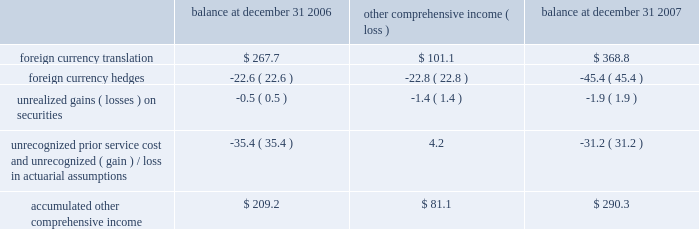Which , $ 44.9 million , or $ 38.2 million , net of taxes , is expected to be reclassified to earnings over the next twelve months .
We also enter into foreign currency forward exchange contracts with terms of one month to manage currency exposures for assets and liabilities denominated in a currency other than an entity 2019s functional currency .
As a result , any foreign currency translation gains/losses recognized in earnings under sfas no .
52 , 201cforeign currency translation 201d are generally offset with gains/losses on the foreign currency forward exchange contracts in the same reporting period .
Other comprehensive income 2013 other comprehensive income refers to revenues , expenses , gains and losses that under generally accepted accounting principles are included in comprehensive income but are excluded from net earnings as these amounts are recorded directly as an adjustment to stockholders 2019 equity .
Other comprehensive income is comprised of foreign currency translation adjustments , unrealized foreign currency hedge gains and losses , unrealized gains and losses on available-for-sale securities and amortization of prior service costs and unrecognized gains and losses in actuarial assumptions .
The components of accumulated other comprehensive income are as follows ( in millions ) : balance at december 31 , comprehensive income ( loss ) balance at december 31 .
Treasury stock 2013 we account for repurchases of common stock under the cost method and present treasury stock as a reduction of shareholders equity .
We may reissue common stock held in treasury only for limited purposes .
Accounting pronouncements 2013 in june 2006 , the fasb issued interpretation no .
48 , 201caccounting for uncertainty in income taxes , an interpretation of fas 109 , accounting for income taxes 201d ( fin 48 ) , to create a single model to address accounting for uncertainty in tax positions .
See our income tax disclosures in note 11 for more information regarding the adoption of fin 48 .
In september 2006 , the fasb issued sfas no .
158 , 201cemployers 2019 accounting for defined benefit pension and other postretirement plans 2013 an amendment of fasb statements no .
87 , 88 , 106 and 132 ( r ) . 201d this statement requires recognition of the funded status of a benefit plan in the statement of financial position .
Sfas no .
158 also requires recognition in other comprehensive income of certain gains and losses that arise during the period but are deferred under pension accounting rules , as well as modifies the timing of reporting and adds certain disclosures .
The statement provides recognition and disclosure elements to be effective as of the end of the fiscal year after december 15 , 2006 and measurement elements to be effective for fiscal years ending after december 15 , 2008 .
We adopted sfas no .
158 on december 31 , 2006 .
See our pension and other postretirement disclosures in note 10 .
In december 2004 , the fasb issued sfas no .
123 ( r ) , 201cshare-based payment 201d , which is a revision to sfas no .
123 .
Sfas 123 ( r ) requires all share-based payments to employees , including stock options , to be expensed based on their fair values .
We adopted sfas 123 ( r ) on january 1 , 2006 using the modified prospective method and did not restate prior periods .
In september 2006 , the fasb issued sfas no .
157 , 201cfair value measurements 201d , which defines fair value , establishes a framework for measuring fair value in generally accepted accounting principles and expands disclosures about fair value measurements .
This statement does not require any new fair value measurements , but provides guidance on how to measure fair value by providing a fair value hierarchy used to classify the source of the information .
Sfas no .
157 is effective for financial statements issued for fiscal years beginning after november 15 , 2007 and interim periods within those fiscal years .
In february 2008 , the fasb issued fasb staff position ( fsp ) no .
Sfas 157-2 , which delays the effective date of certain provisions of sfas no .
157 relating to non-financial assets and liabilities measured at fair value on a non-recurring basis until fiscal years beginning after november 15 , 2008 .
The adoption of sfas no .
157 is not expected to have a material impact on our consolidated financial statements or results of operations .
In february 2007 , the fasb issued sfas no .
159 , 201cthe fair value option for financial assets and financial liabilities 2013 including an amendment of fasb statement no .
115 201d ( sfas no .
159 ) .
Sfas no .
159 creates a 201cfair value option 201d under which an entity may elect to record certain financial assets or liabilities at fair value upon their initial recognition .
Subsequent changes in fair value would be recognized in earnings as those changes occur .
The election of the fair value option would be made on a contract-by-contract basis and would need to be supported by concurrent documentation or a preexisting documented policy .
Sfas no .
159 requires an entity to separately disclose the fair z i m m e r h o l d i n g s , i n c .
2 0 0 7 f o r m 1 0 - k a n n u a l r e p o r t notes to consolidated financial statements ( continued ) .
What percent of total accumulated other comprehensive income is from 2007? 
Computations: (81.1 / 290.3)
Answer: 0.27937. Which , $ 44.9 million , or $ 38.2 million , net of taxes , is expected to be reclassified to earnings over the next twelve months .
We also enter into foreign currency forward exchange contracts with terms of one month to manage currency exposures for assets and liabilities denominated in a currency other than an entity 2019s functional currency .
As a result , any foreign currency translation gains/losses recognized in earnings under sfas no .
52 , 201cforeign currency translation 201d are generally offset with gains/losses on the foreign currency forward exchange contracts in the same reporting period .
Other comprehensive income 2013 other comprehensive income refers to revenues , expenses , gains and losses that under generally accepted accounting principles are included in comprehensive income but are excluded from net earnings as these amounts are recorded directly as an adjustment to stockholders 2019 equity .
Other comprehensive income is comprised of foreign currency translation adjustments , unrealized foreign currency hedge gains and losses , unrealized gains and losses on available-for-sale securities and amortization of prior service costs and unrecognized gains and losses in actuarial assumptions .
The components of accumulated other comprehensive income are as follows ( in millions ) : balance at december 31 , comprehensive income ( loss ) balance at december 31 .
Treasury stock 2013 we account for repurchases of common stock under the cost method and present treasury stock as a reduction of shareholders equity .
We may reissue common stock held in treasury only for limited purposes .
Accounting pronouncements 2013 in june 2006 , the fasb issued interpretation no .
48 , 201caccounting for uncertainty in income taxes , an interpretation of fas 109 , accounting for income taxes 201d ( fin 48 ) , to create a single model to address accounting for uncertainty in tax positions .
See our income tax disclosures in note 11 for more information regarding the adoption of fin 48 .
In september 2006 , the fasb issued sfas no .
158 , 201cemployers 2019 accounting for defined benefit pension and other postretirement plans 2013 an amendment of fasb statements no .
87 , 88 , 106 and 132 ( r ) . 201d this statement requires recognition of the funded status of a benefit plan in the statement of financial position .
Sfas no .
158 also requires recognition in other comprehensive income of certain gains and losses that arise during the period but are deferred under pension accounting rules , as well as modifies the timing of reporting and adds certain disclosures .
The statement provides recognition and disclosure elements to be effective as of the end of the fiscal year after december 15 , 2006 and measurement elements to be effective for fiscal years ending after december 15 , 2008 .
We adopted sfas no .
158 on december 31 , 2006 .
See our pension and other postretirement disclosures in note 10 .
In december 2004 , the fasb issued sfas no .
123 ( r ) , 201cshare-based payment 201d , which is a revision to sfas no .
123 .
Sfas 123 ( r ) requires all share-based payments to employees , including stock options , to be expensed based on their fair values .
We adopted sfas 123 ( r ) on january 1 , 2006 using the modified prospective method and did not restate prior periods .
In september 2006 , the fasb issued sfas no .
157 , 201cfair value measurements 201d , which defines fair value , establishes a framework for measuring fair value in generally accepted accounting principles and expands disclosures about fair value measurements .
This statement does not require any new fair value measurements , but provides guidance on how to measure fair value by providing a fair value hierarchy used to classify the source of the information .
Sfas no .
157 is effective for financial statements issued for fiscal years beginning after november 15 , 2007 and interim periods within those fiscal years .
In february 2008 , the fasb issued fasb staff position ( fsp ) no .
Sfas 157-2 , which delays the effective date of certain provisions of sfas no .
157 relating to non-financial assets and liabilities measured at fair value on a non-recurring basis until fiscal years beginning after november 15 , 2008 .
The adoption of sfas no .
157 is not expected to have a material impact on our consolidated financial statements or results of operations .
In february 2007 , the fasb issued sfas no .
159 , 201cthe fair value option for financial assets and financial liabilities 2013 including an amendment of fasb statement no .
115 201d ( sfas no .
159 ) .
Sfas no .
159 creates a 201cfair value option 201d under which an entity may elect to record certain financial assets or liabilities at fair value upon their initial recognition .
Subsequent changes in fair value would be recognized in earnings as those changes occur .
The election of the fair value option would be made on a contract-by-contract basis and would need to be supported by concurrent documentation or a preexisting documented policy .
Sfas no .
159 requires an entity to separately disclose the fair z i m m e r h o l d i n g s , i n c .
2 0 0 7 f o r m 1 0 - k a n n u a l r e p o r t notes to consolidated financial statements ( continued ) .
What percent of gains were lost due to foreign currency hedges? 
Computations: (45.4 / 368.8)
Answer: 0.1231. 